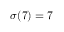<formula> <loc_0><loc_0><loc_500><loc_500>\sigma ( 7 ) = 7</formula> 